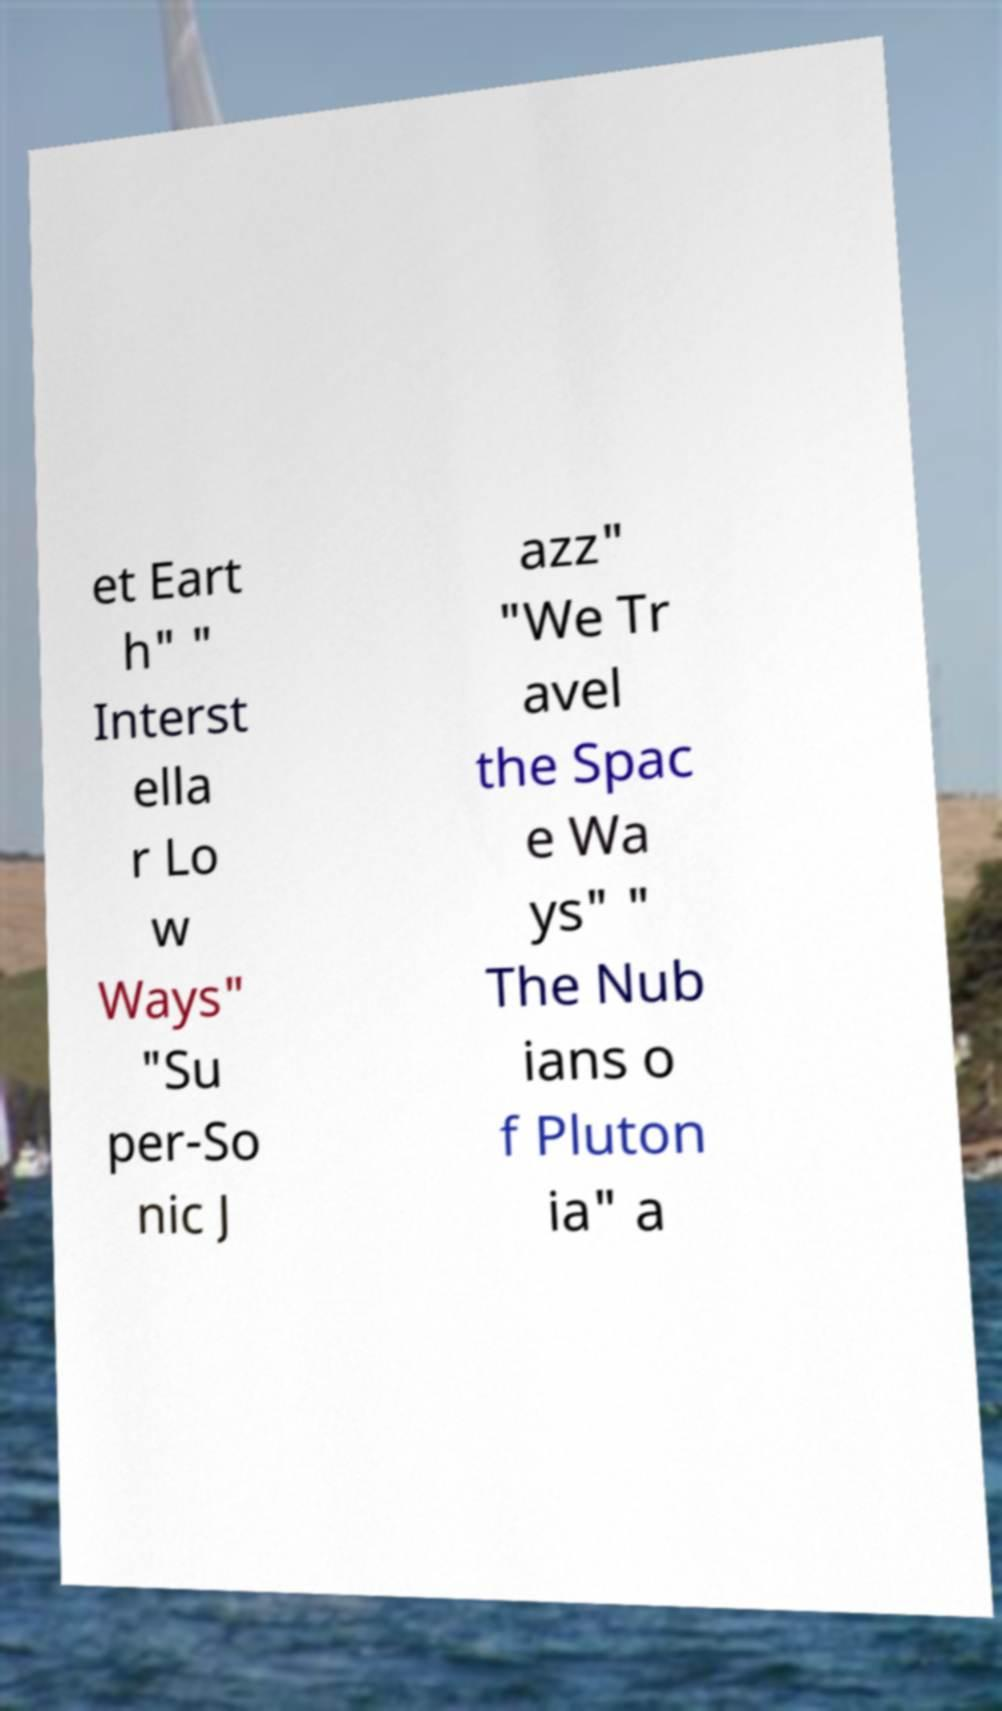Please identify and transcribe the text found in this image. et Eart h" " Interst ella r Lo w Ways" "Su per-So nic J azz" "We Tr avel the Spac e Wa ys" " The Nub ians o f Pluton ia" a 